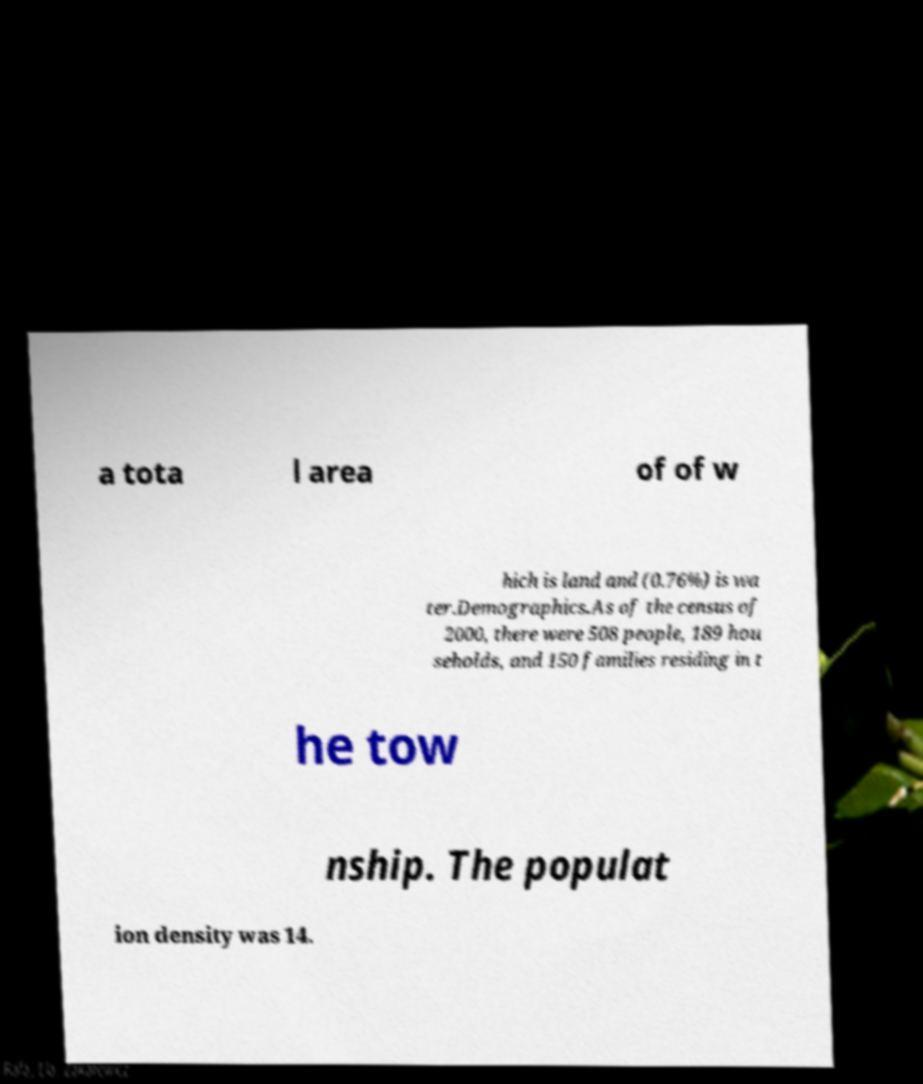Please identify and transcribe the text found in this image. a tota l area of of w hich is land and (0.76%) is wa ter.Demographics.As of the census of 2000, there were 508 people, 189 hou seholds, and 150 families residing in t he tow nship. The populat ion density was 14. 